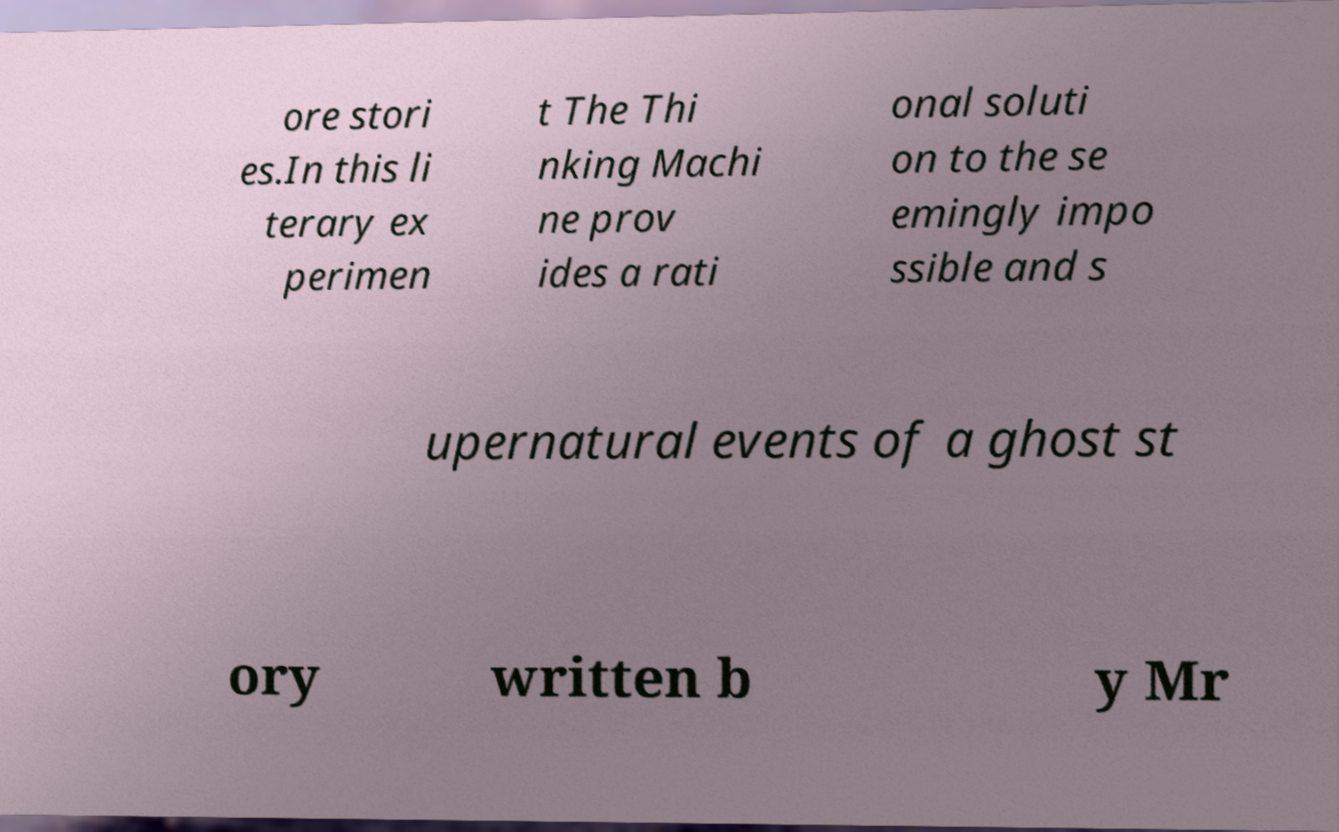What messages or text are displayed in this image? I need them in a readable, typed format. ore stori es.In this li terary ex perimen t The Thi nking Machi ne prov ides a rati onal soluti on to the se emingly impo ssible and s upernatural events of a ghost st ory written b y Mr 